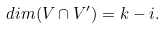<formula> <loc_0><loc_0><loc_500><loc_500>d i m ( V \cap V ^ { \prime } ) = k - i .</formula> 